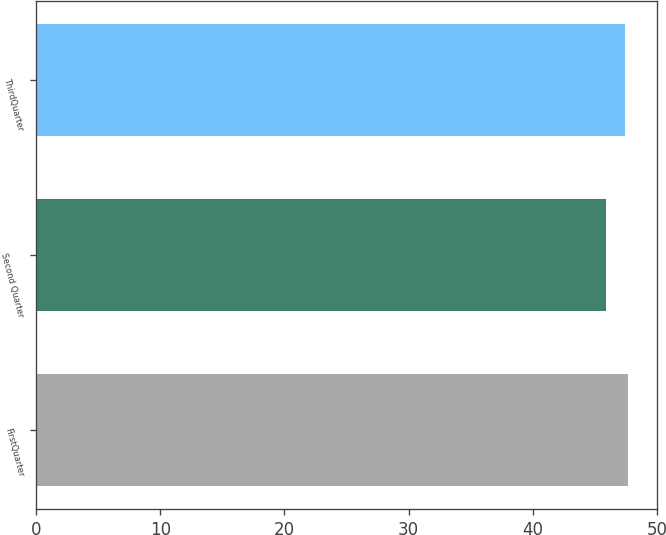Convert chart. <chart><loc_0><loc_0><loc_500><loc_500><bar_chart><fcel>FirstQuarter<fcel>Second Quarter<fcel>ThirdQuarter<nl><fcel>47.65<fcel>45.86<fcel>47.39<nl></chart> 